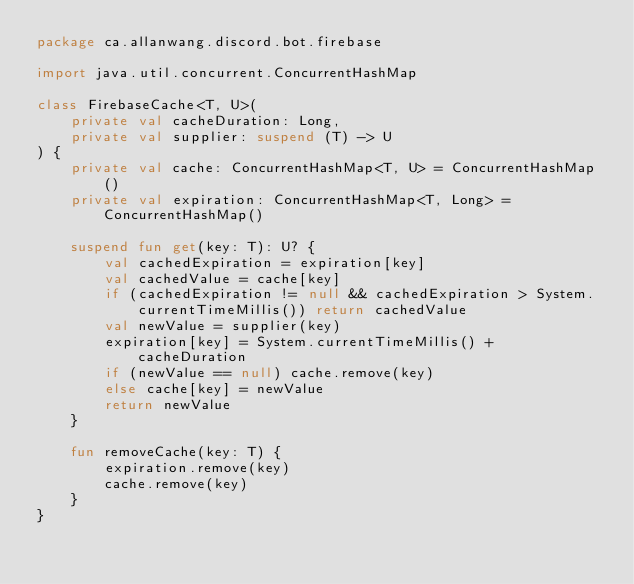<code> <loc_0><loc_0><loc_500><loc_500><_Kotlin_>package ca.allanwang.discord.bot.firebase

import java.util.concurrent.ConcurrentHashMap

class FirebaseCache<T, U>(
    private val cacheDuration: Long,
    private val supplier: suspend (T) -> U
) {
    private val cache: ConcurrentHashMap<T, U> = ConcurrentHashMap()
    private val expiration: ConcurrentHashMap<T, Long> = ConcurrentHashMap()

    suspend fun get(key: T): U? {
        val cachedExpiration = expiration[key]
        val cachedValue = cache[key]
        if (cachedExpiration != null && cachedExpiration > System.currentTimeMillis()) return cachedValue
        val newValue = supplier(key)
        expiration[key] = System.currentTimeMillis() + cacheDuration
        if (newValue == null) cache.remove(key)
        else cache[key] = newValue
        return newValue
    }

    fun removeCache(key: T) {
        expiration.remove(key)
        cache.remove(key)
    }
}
</code> 